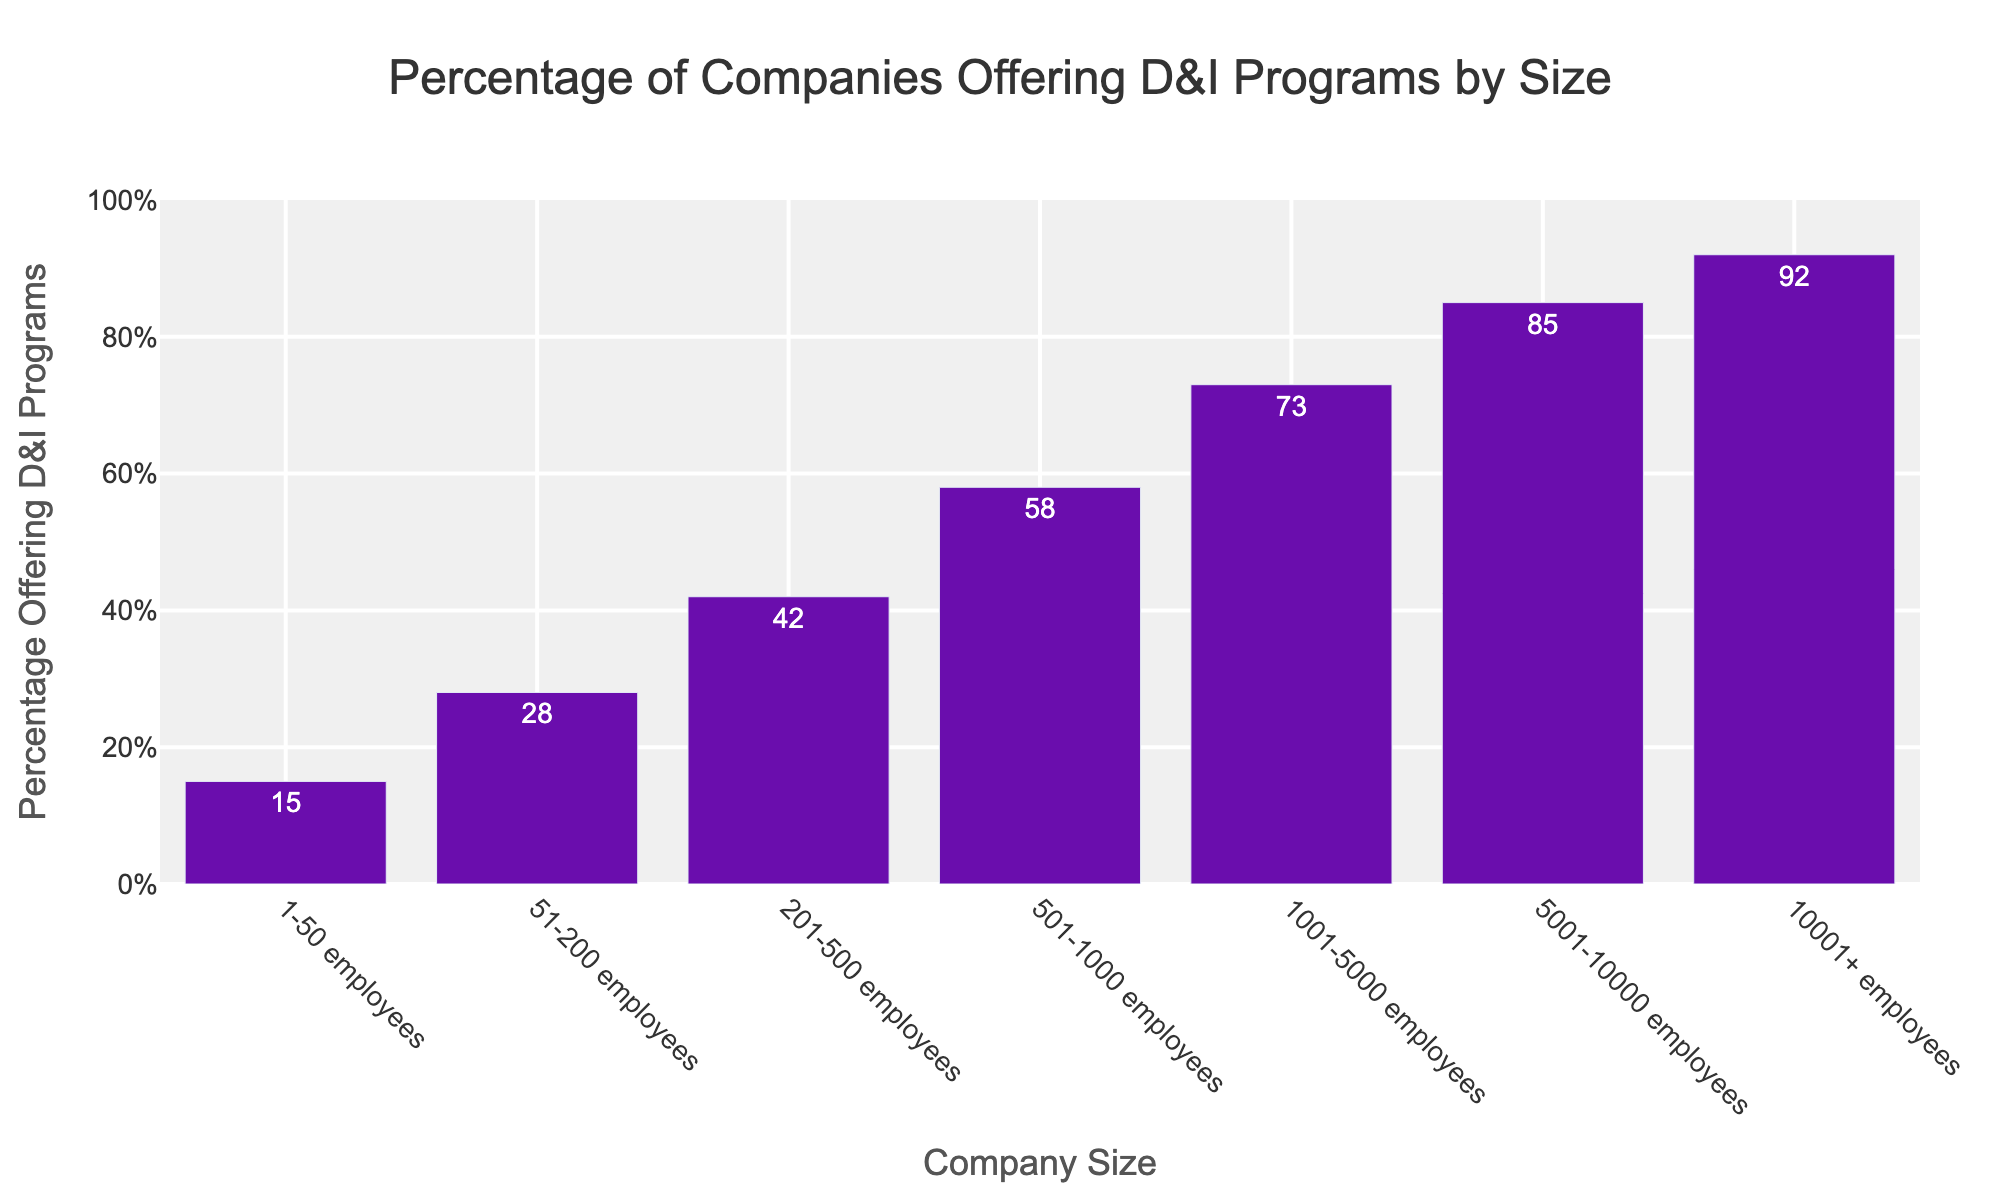What's the percentage of companies with 1-50 employees offering D&I programs? Look at the bar corresponding to the company size '1-50 employees' and read the percentage on the bar or the text displayed above the bar.
Answer: 15% Which company size has the highest percentage of companies offering D&I programs? Look for the tallest bar in the chart and read the corresponding company size.
Answer: 10001+ employees Is the percentage of companies offering D&I programs higher for companies with 501-1000 employees or 201-500 employees? Compare the heights of the bars corresponding to '501-1000 employees' and '201-500 employees' or the text displayed above the bars.
Answer: 501-1000 employees What is the difference in percentage of companies offering D&I programs between the largest (10001+ employees) and the smallest (1-50 employees) company sizes? Subtract the percentage for '1-50 employees' from the percentage for '10001+ employees'. Calculation: 92% - 15% = 77%.
Answer: 77% What can you infer about the overall trend of D&I programs in relation to company size? Observe that the height of the bars increases as the company size increases, indicating a positive correlation between company size and the percentage of companies offering D&I programs.
Answer: Larger companies tend to offer D&I programs more frequently Calculate the average percentage of companies offering D&I programs for companies with 201-1000 employees. Add the percentages for company sizes 201-500, 501-1000 and divide by the number of groups. Calculation: (42% + 58%) / 2 = 50%.
Answer: 50% Which company size has a percentage of companies offering D&I programs closest to 50%? Find the bar whose percentage is the closest to 50% by comparing the text displayed above the bars.
Answer: 501-1000 employees How much higher is the percentage of companies offering D&I programs for companies with 5001-10000 employees compared to companies with 51-200 employees? Subtract the percentage for '51-200 employees' from the percentage for '5001-10000 employees'. Calculation: 85% - 28% = 57%.
Answer: 57% What percentage range do the majority of company sizes fall into for offering D&I programs? Observe the distribution of the bars and identify the range where most bars fall within. The majority of the company sizes have percentages between 15% and 92%.
Answer: 15% to 92% Determine the median percentage of companies offering D&I programs by ordering the percentages and finding the middle value. Arrange the percentages in ascending order and find the middle number (15, 28, 42, 58, 73, 85, 92). The median percentage is 58%.
Answer: 58% 